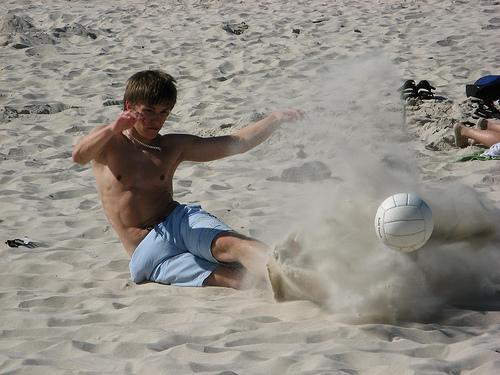What color are the shorts the boy is wearing and what is he doing? The boy is wearing blue shorts and diving into the sand, seemingly kicking the white volleyball. Describe the scene involving sand on the beach. A tan, light brown sandy beach has tracks, a small pile of sand, and a man diving into the sand while kicking a volleyball. Examine and explain the elements surrounding the boy in blue shorts. The boy in blue shorts is in the sand with tracks, a white volleyball flying in the air, glasses nearby, and a pair of black shoes on the sand. Give a brief description of a person lying on the sand in the image. A person is lying on the sand with bare legs and sandy feet, seemingly relaxing or sunbathing. Enumerate three different objects found on the sand in the image. A pair of black shoes, a small pile of sand, and a blue and black bag are objects found on the sand. What can be inferred about the boy's appearance from the image? The boy has brown hair, wears a white shell necklace, and has on blue shorts. What is happening with the volleyball in the image and provide the color of the volleyball? A hard white volleyball is airbound, flying through the air as it gets kicked. Can you briefly describe the appearance and position of the pair of shoes in the image? There is a pair of black shoes or sandals placed on the sand, not being worn by anyone. Identify two elements related to a person's body in the image. A person's legs and a man's chest can be seen in the image. Describe the action involving the volleyball in the image. A white volleyball is flying through the air as a young man kicks it, creating a cloud of sandy dust in the air. 